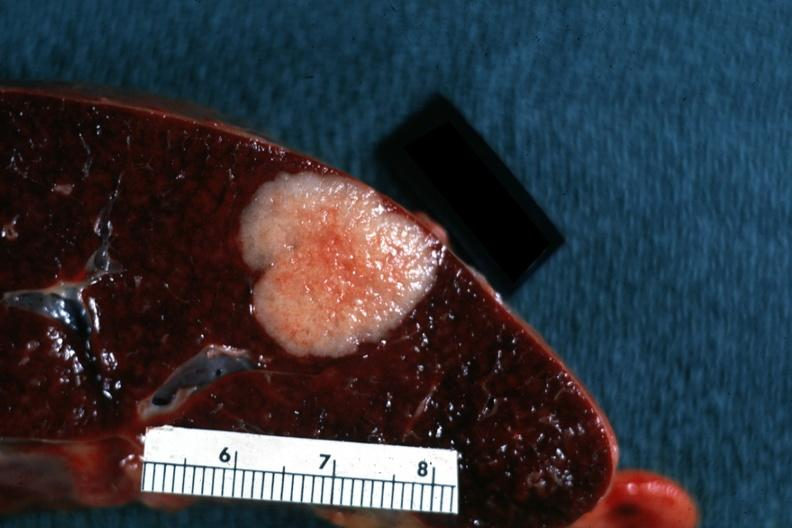where is this part in?
Answer the question using a single word or phrase. Spleen 